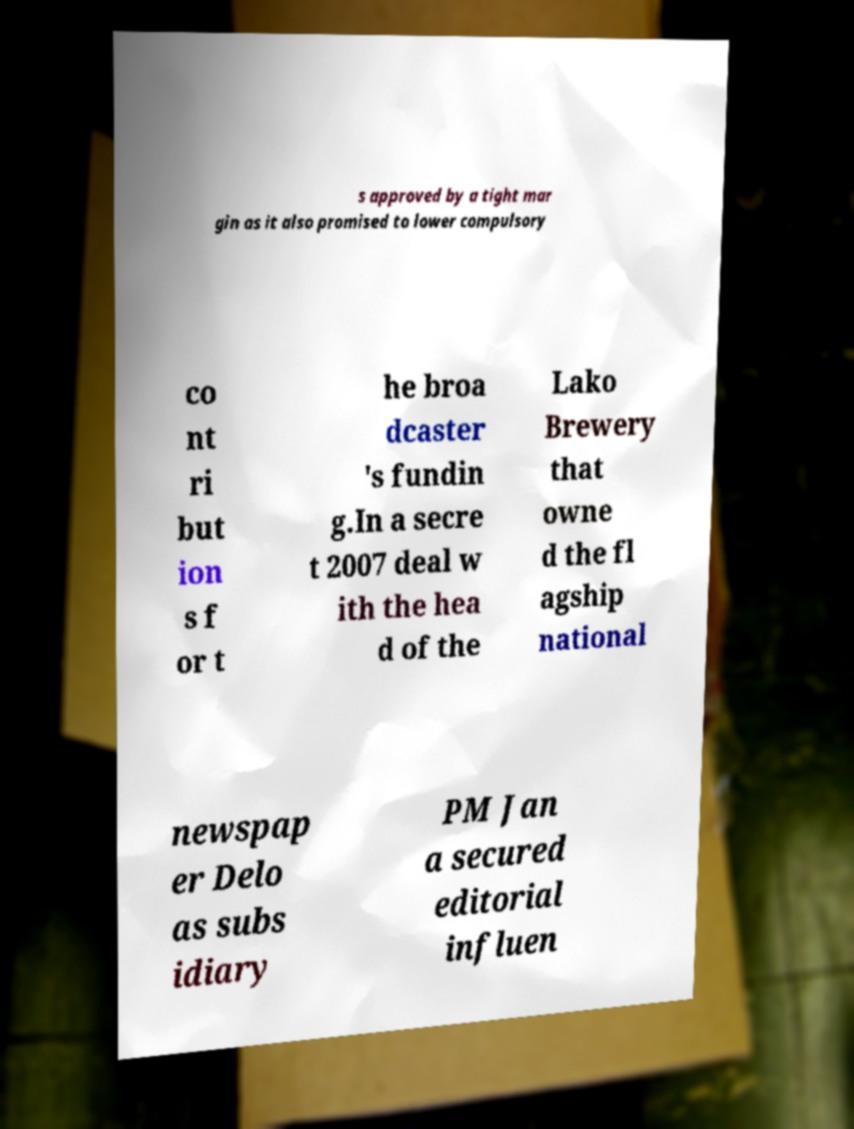Could you assist in decoding the text presented in this image and type it out clearly? s approved by a tight mar gin as it also promised to lower compulsory co nt ri but ion s f or t he broa dcaster 's fundin g.In a secre t 2007 deal w ith the hea d of the Lako Brewery that owne d the fl agship national newspap er Delo as subs idiary PM Jan a secured editorial influen 